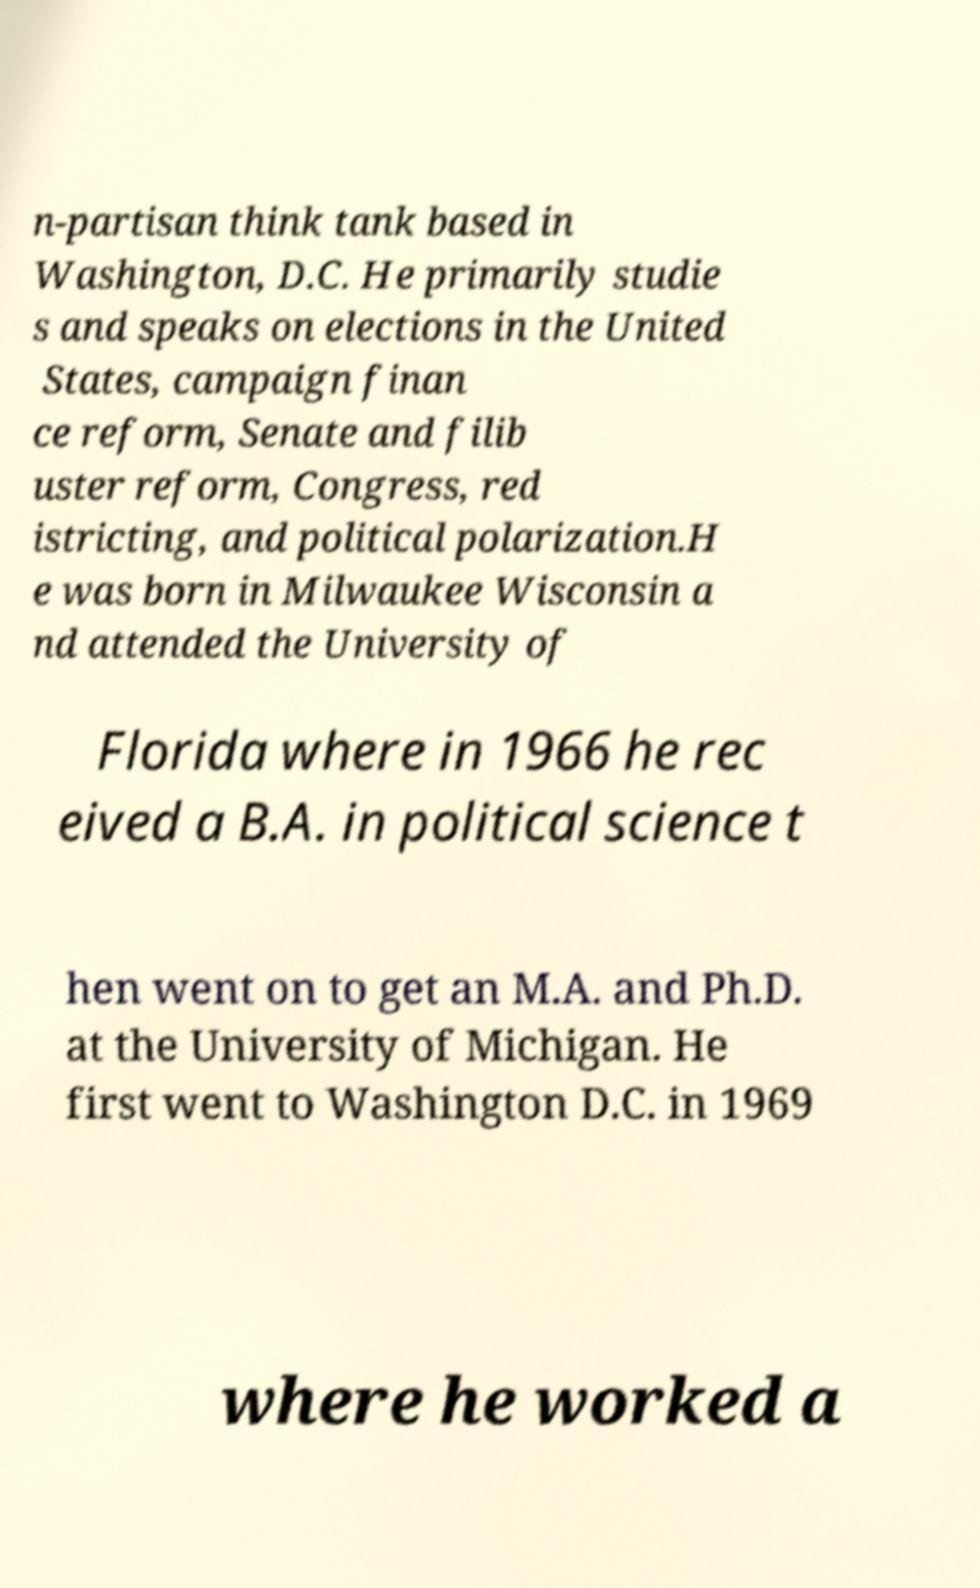There's text embedded in this image that I need extracted. Can you transcribe it verbatim? n-partisan think tank based in Washington, D.C. He primarily studie s and speaks on elections in the United States, campaign finan ce reform, Senate and filib uster reform, Congress, red istricting, and political polarization.H e was born in Milwaukee Wisconsin a nd attended the University of Florida where in 1966 he rec eived a B.A. in political science t hen went on to get an M.A. and Ph.D. at the University of Michigan. He first went to Washington D.C. in 1969 where he worked a 